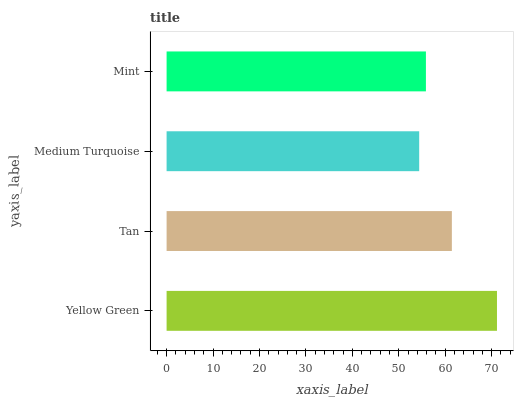Is Medium Turquoise the minimum?
Answer yes or no. Yes. Is Yellow Green the maximum?
Answer yes or no. Yes. Is Tan the minimum?
Answer yes or no. No. Is Tan the maximum?
Answer yes or no. No. Is Yellow Green greater than Tan?
Answer yes or no. Yes. Is Tan less than Yellow Green?
Answer yes or no. Yes. Is Tan greater than Yellow Green?
Answer yes or no. No. Is Yellow Green less than Tan?
Answer yes or no. No. Is Tan the high median?
Answer yes or no. Yes. Is Mint the low median?
Answer yes or no. Yes. Is Medium Turquoise the high median?
Answer yes or no. No. Is Medium Turquoise the low median?
Answer yes or no. No. 